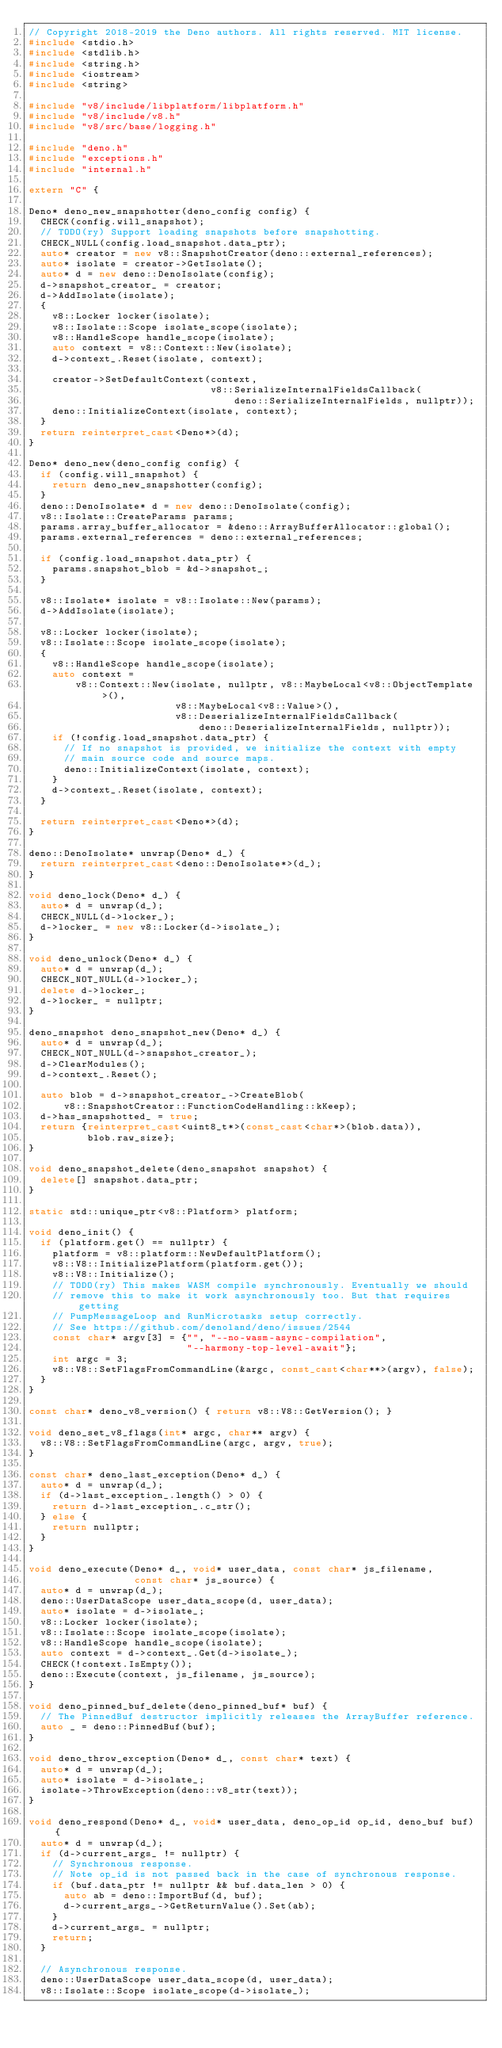Convert code to text. <code><loc_0><loc_0><loc_500><loc_500><_C++_>// Copyright 2018-2019 the Deno authors. All rights reserved. MIT license.
#include <stdio.h>
#include <stdlib.h>
#include <string.h>
#include <iostream>
#include <string>

#include "v8/include/libplatform/libplatform.h"
#include "v8/include/v8.h"
#include "v8/src/base/logging.h"

#include "deno.h"
#include "exceptions.h"
#include "internal.h"

extern "C" {

Deno* deno_new_snapshotter(deno_config config) {
  CHECK(config.will_snapshot);
  // TODO(ry) Support loading snapshots before snapshotting.
  CHECK_NULL(config.load_snapshot.data_ptr);
  auto* creator = new v8::SnapshotCreator(deno::external_references);
  auto* isolate = creator->GetIsolate();
  auto* d = new deno::DenoIsolate(config);
  d->snapshot_creator_ = creator;
  d->AddIsolate(isolate);
  {
    v8::Locker locker(isolate);
    v8::Isolate::Scope isolate_scope(isolate);
    v8::HandleScope handle_scope(isolate);
    auto context = v8::Context::New(isolate);
    d->context_.Reset(isolate, context);

    creator->SetDefaultContext(context,
                               v8::SerializeInternalFieldsCallback(
                                   deno::SerializeInternalFields, nullptr));
    deno::InitializeContext(isolate, context);
  }
  return reinterpret_cast<Deno*>(d);
}

Deno* deno_new(deno_config config) {
  if (config.will_snapshot) {
    return deno_new_snapshotter(config);
  }
  deno::DenoIsolate* d = new deno::DenoIsolate(config);
  v8::Isolate::CreateParams params;
  params.array_buffer_allocator = &deno::ArrayBufferAllocator::global();
  params.external_references = deno::external_references;

  if (config.load_snapshot.data_ptr) {
    params.snapshot_blob = &d->snapshot_;
  }

  v8::Isolate* isolate = v8::Isolate::New(params);
  d->AddIsolate(isolate);

  v8::Locker locker(isolate);
  v8::Isolate::Scope isolate_scope(isolate);
  {
    v8::HandleScope handle_scope(isolate);
    auto context =
        v8::Context::New(isolate, nullptr, v8::MaybeLocal<v8::ObjectTemplate>(),
                         v8::MaybeLocal<v8::Value>(),
                         v8::DeserializeInternalFieldsCallback(
                             deno::DeserializeInternalFields, nullptr));
    if (!config.load_snapshot.data_ptr) {
      // If no snapshot is provided, we initialize the context with empty
      // main source code and source maps.
      deno::InitializeContext(isolate, context);
    }
    d->context_.Reset(isolate, context);
  }

  return reinterpret_cast<Deno*>(d);
}

deno::DenoIsolate* unwrap(Deno* d_) {
  return reinterpret_cast<deno::DenoIsolate*>(d_);
}

void deno_lock(Deno* d_) {
  auto* d = unwrap(d_);
  CHECK_NULL(d->locker_);
  d->locker_ = new v8::Locker(d->isolate_);
}

void deno_unlock(Deno* d_) {
  auto* d = unwrap(d_);
  CHECK_NOT_NULL(d->locker_);
  delete d->locker_;
  d->locker_ = nullptr;
}

deno_snapshot deno_snapshot_new(Deno* d_) {
  auto* d = unwrap(d_);
  CHECK_NOT_NULL(d->snapshot_creator_);
  d->ClearModules();
  d->context_.Reset();

  auto blob = d->snapshot_creator_->CreateBlob(
      v8::SnapshotCreator::FunctionCodeHandling::kKeep);
  d->has_snapshotted_ = true;
  return {reinterpret_cast<uint8_t*>(const_cast<char*>(blob.data)),
          blob.raw_size};
}

void deno_snapshot_delete(deno_snapshot snapshot) {
  delete[] snapshot.data_ptr;
}

static std::unique_ptr<v8::Platform> platform;

void deno_init() {
  if (platform.get() == nullptr) {
    platform = v8::platform::NewDefaultPlatform();
    v8::V8::InitializePlatform(platform.get());
    v8::V8::Initialize();
    // TODO(ry) This makes WASM compile synchronously. Eventually we should
    // remove this to make it work asynchronously too. But that requires getting
    // PumpMessageLoop and RunMicrotasks setup correctly.
    // See https://github.com/denoland/deno/issues/2544
    const char* argv[3] = {"", "--no-wasm-async-compilation",
                           "--harmony-top-level-await"};
    int argc = 3;
    v8::V8::SetFlagsFromCommandLine(&argc, const_cast<char**>(argv), false);
  }
}

const char* deno_v8_version() { return v8::V8::GetVersion(); }

void deno_set_v8_flags(int* argc, char** argv) {
  v8::V8::SetFlagsFromCommandLine(argc, argv, true);
}

const char* deno_last_exception(Deno* d_) {
  auto* d = unwrap(d_);
  if (d->last_exception_.length() > 0) {
    return d->last_exception_.c_str();
  } else {
    return nullptr;
  }
}

void deno_execute(Deno* d_, void* user_data, const char* js_filename,
                  const char* js_source) {
  auto* d = unwrap(d_);
  deno::UserDataScope user_data_scope(d, user_data);
  auto* isolate = d->isolate_;
  v8::Locker locker(isolate);
  v8::Isolate::Scope isolate_scope(isolate);
  v8::HandleScope handle_scope(isolate);
  auto context = d->context_.Get(d->isolate_);
  CHECK(!context.IsEmpty());
  deno::Execute(context, js_filename, js_source);
}

void deno_pinned_buf_delete(deno_pinned_buf* buf) {
  // The PinnedBuf destructor implicitly releases the ArrayBuffer reference.
  auto _ = deno::PinnedBuf(buf);
}

void deno_throw_exception(Deno* d_, const char* text) {
  auto* d = unwrap(d_);
  auto* isolate = d->isolate_;
  isolate->ThrowException(deno::v8_str(text));
}

void deno_respond(Deno* d_, void* user_data, deno_op_id op_id, deno_buf buf) {
  auto* d = unwrap(d_);
  if (d->current_args_ != nullptr) {
    // Synchronous response.
    // Note op_id is not passed back in the case of synchronous response.
    if (buf.data_ptr != nullptr && buf.data_len > 0) {
      auto ab = deno::ImportBuf(d, buf);
      d->current_args_->GetReturnValue().Set(ab);
    }
    d->current_args_ = nullptr;
    return;
  }

  // Asynchronous response.
  deno::UserDataScope user_data_scope(d, user_data);
  v8::Isolate::Scope isolate_scope(d->isolate_);</code> 